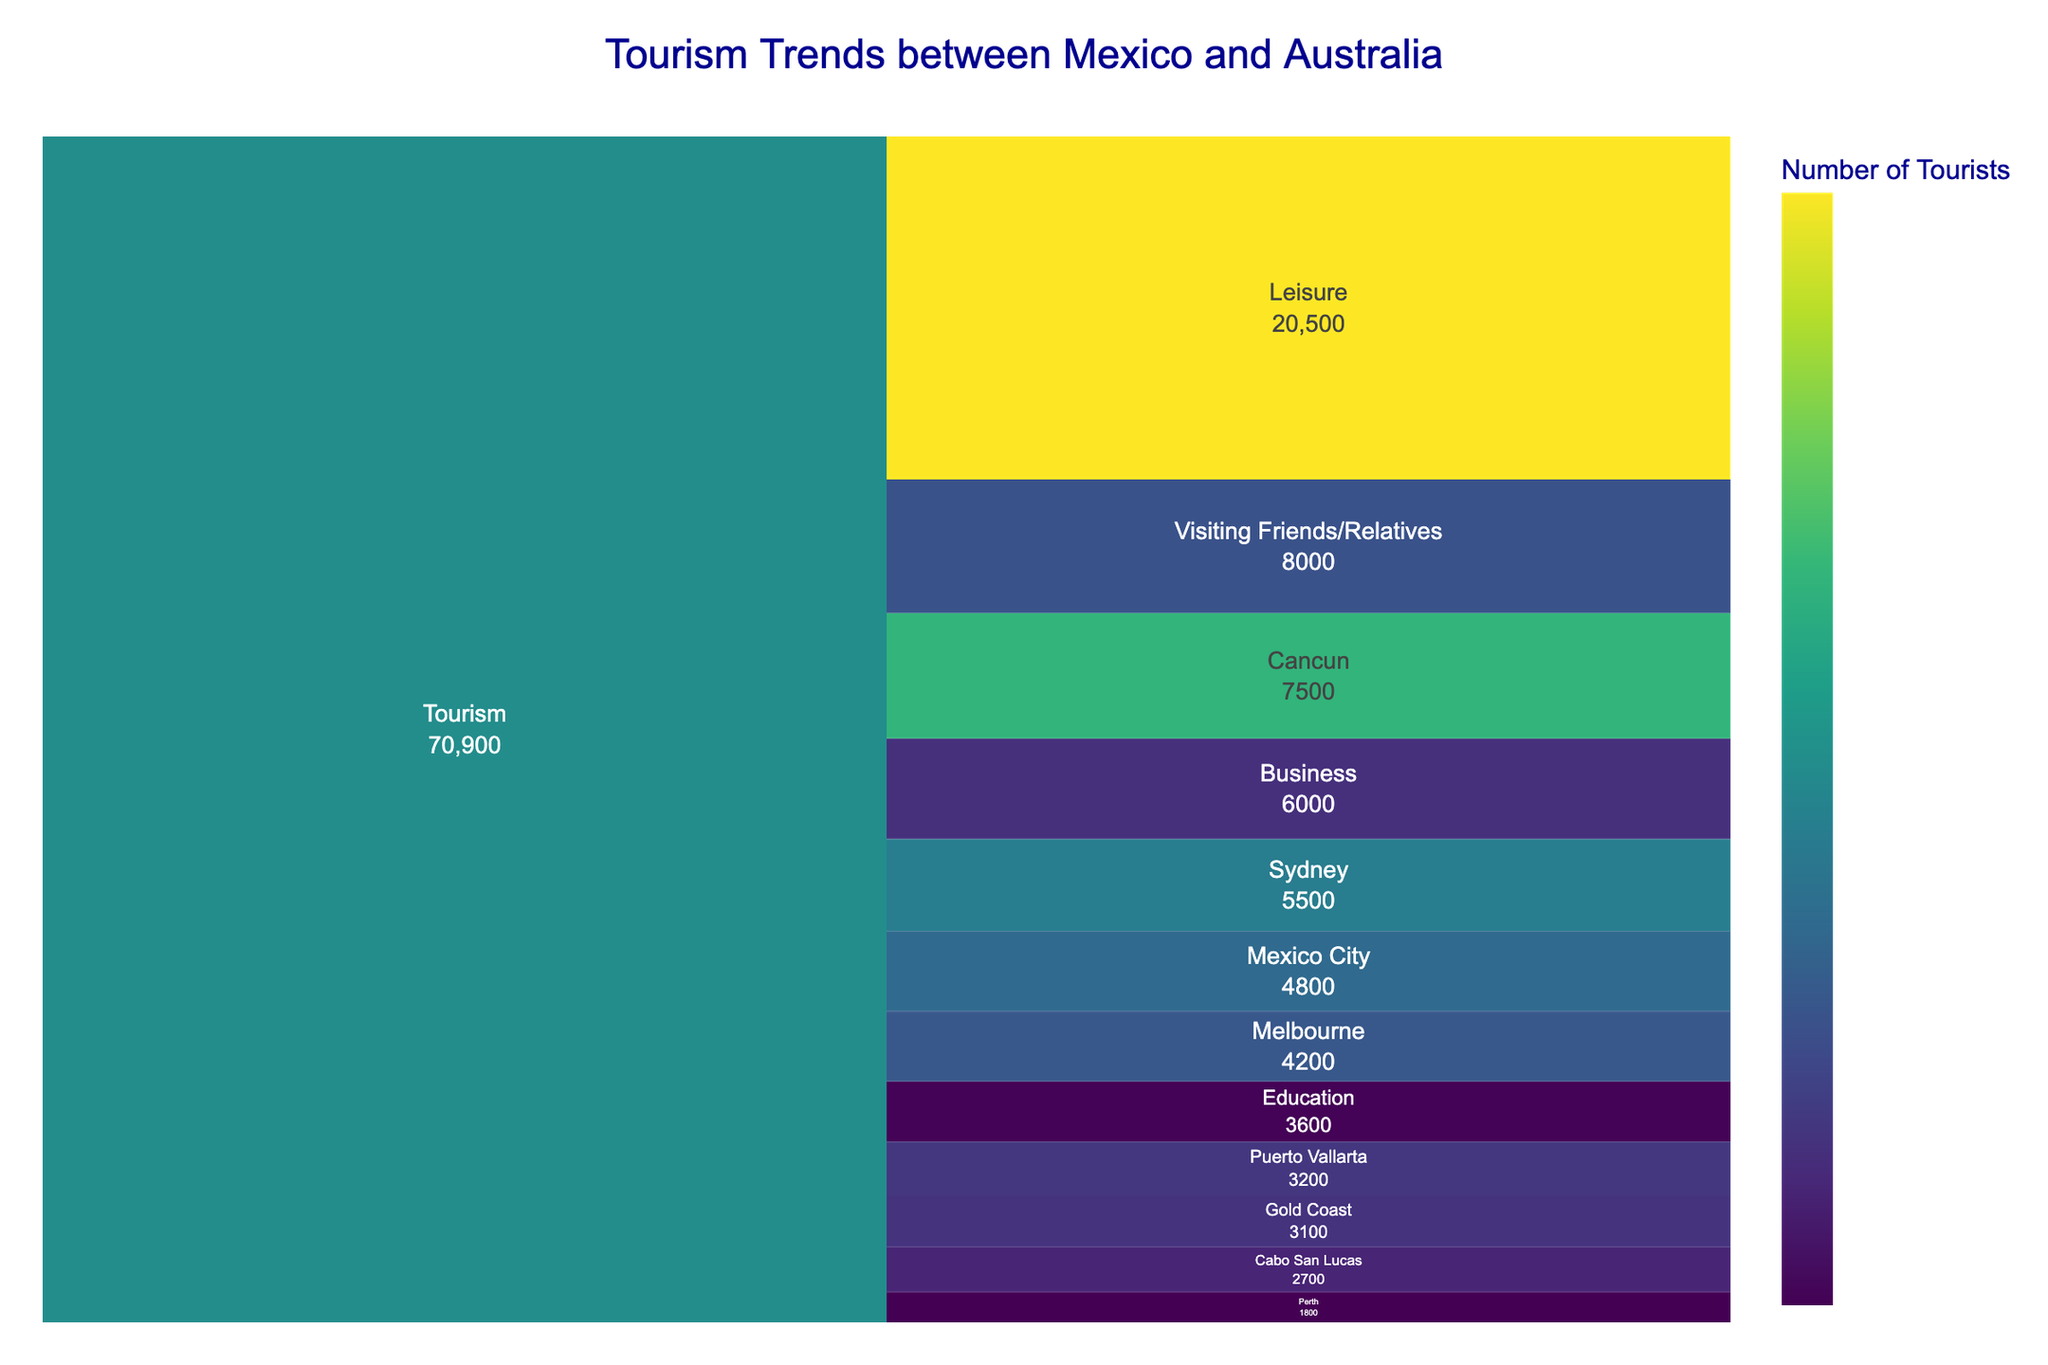What is the most popular travel purpose for Mexican tourists visiting Australia? Refer to the icicle chart and identify the segment with the highest value for "Mexico to Australia" category. The segment "Leisure" has the highest value (8500).
Answer: Leisure What is the least common travel purpose for Australian tourists visiting Mexico? Refer to the icicle chart and identify the segment with the lowest value for "Australia to Mexico" category. The segment "Education" has the lowest value (1500).
Answer: Education How many more tourists traveled from Mexico to Australia for business compared to education? Identify the values for "Business" and "Education" under the "Mexico to Australia" category. Subtract the value of Education from Business: 3200 - 2100 = 1100.
Answer: 1100 Which city in Australia did the most Mexican tourists visit? Refer to the icicle chart under the "Mexico to Australia" category and identify which city has the highest value. The city "Sydney" has the highest value (5500).
Answer: Sydney What is the total number of tourists traveling from Mexico to Australia? Sum all the values listed under "Mexico to Australia" category: 3200 (Business) + 8500 (Leisure) + 2100 (Education) + 4300 (Visiting Friends/Relatives) = 18100.
Answer: 18100 How does the number of tourists traveling from Australia to Mexico for leisure compare to the number traveling for business? Identify the values for "Leisure" and "Business" under the "Australia to Mexico" category. Compare the values: Leisure (12000) is much higher than Business (2800).
Answer: Leisure is much higher than Business Which Mexican destination had the fewest Australian tourists? Refer to the icicle chart under the "Australia to Mexico" category and identify which destination has the lowest value. "Cabo San Lucas" has the lowest value (2700).
Answer: Cabo San Lucas What is the average number of tourists per purpose for those traveling from Mexico to Australia? Identify the values for each purpose under "Mexico to Australia": 3200 (Business), 8500 (Leisure), 2100 (Education), 4300 (Visiting Friends/Relatives). Calculate the average: (3200 + 8500 + 2100 + 4300) / 4 = 4525.
Answer: 4525 What is the total number of Mexican tourists visiting Sydney, Melbourne, and Gold Coast? Sum the values for Sydney, Melbourne, and Gold Coast under "Mexico to Australia": 5500 (Sydney) + 4200 (Melbourne) + 3100 (Gold Coast) = 12800.
Answer: 12800 